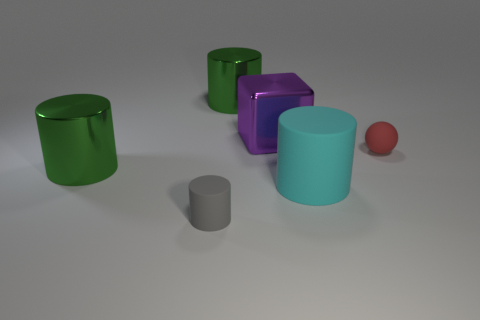Does the gray thing have the same material as the tiny thing that is to the right of the gray rubber object?
Offer a terse response. Yes. Is the shape of the gray object the same as the cyan thing?
Offer a very short reply. Yes. How many other metal things are the same shape as the gray thing?
Ensure brevity in your answer.  2. What is the color of the cylinder that is both behind the cyan matte object and right of the small gray matte object?
Your answer should be compact. Green. What number of red rubber things are there?
Give a very brief answer. 1. Is the size of the red rubber sphere the same as the cyan cylinder?
Keep it short and to the point. No. Do the small thing to the left of the big purple shiny thing and the cyan object have the same shape?
Ensure brevity in your answer.  Yes. How many metallic objects are the same size as the cyan rubber object?
Offer a very short reply. 3. How many objects are left of the small thing in front of the matte ball?
Keep it short and to the point. 1. Is the large green cylinder that is on the left side of the gray cylinder made of the same material as the tiny gray cylinder?
Provide a succinct answer. No. 